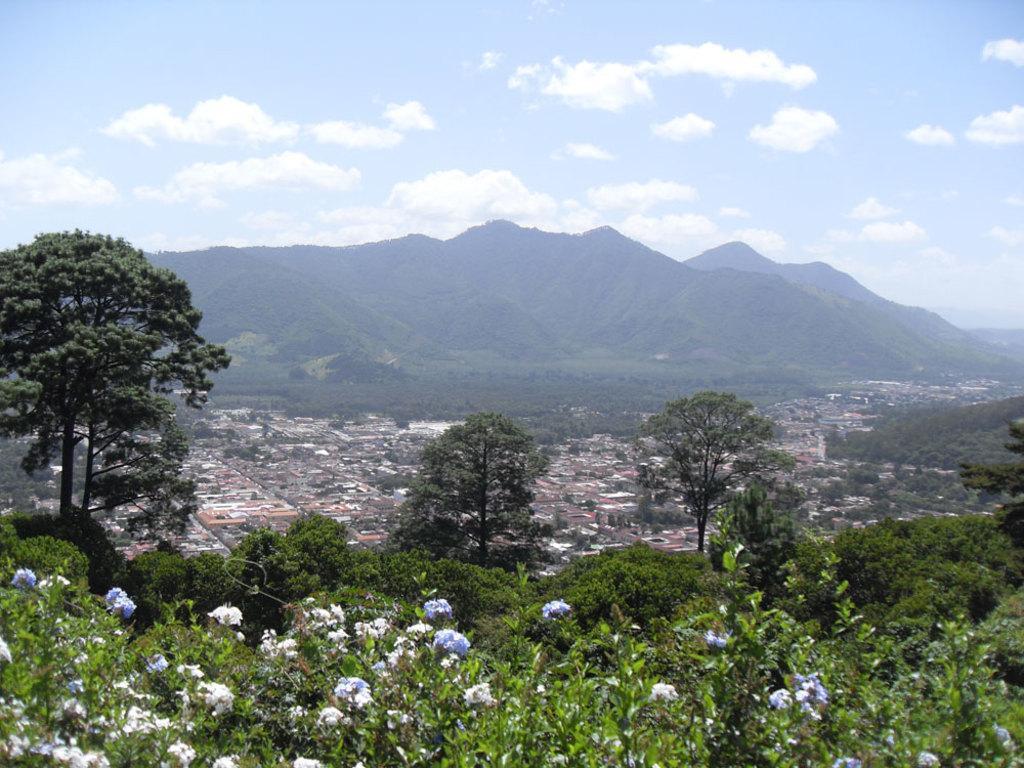Describe this image in one or two sentences. This picture is clicked outside. In the foreground we can see the flowers and the green leaves and we can see the trees. In the center we can see the group of houses and we can see the hills, green grass and many other objects. In the background we can see the sky with the clouds. 